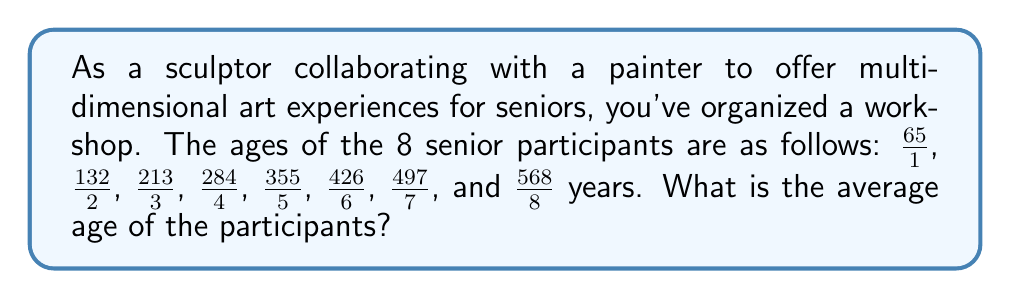What is the answer to this math problem? To find the average age, we need to follow these steps:

1) First, simplify each fraction:
   $\frac{65}{1} = 65$, $\frac{132}{2} = 66$, $\frac{213}{3} = 71$, $\frac{284}{4} = 71$, 
   $\frac{355}{5} = 71$, $\frac{426}{6} = 71$, $\frac{497}{7} = 71$, $\frac{568}{8} = 71$

2) Now, add all the simplified ages:
   $65 + 66 + 71 + 71 + 71 + 71 + 71 + 71 = 557$

3) To find the average, divide the sum by the number of participants:
   $$\text{Average} = \frac{\text{Sum of ages}}{\text{Number of participants}} = \frac{557}{8}$$

4) Simplify this fraction:
   $$\frac{557}{8} = 69.625$$

Therefore, the average age of the senior participants is 69.625 years.
Answer: $69.625$ years 